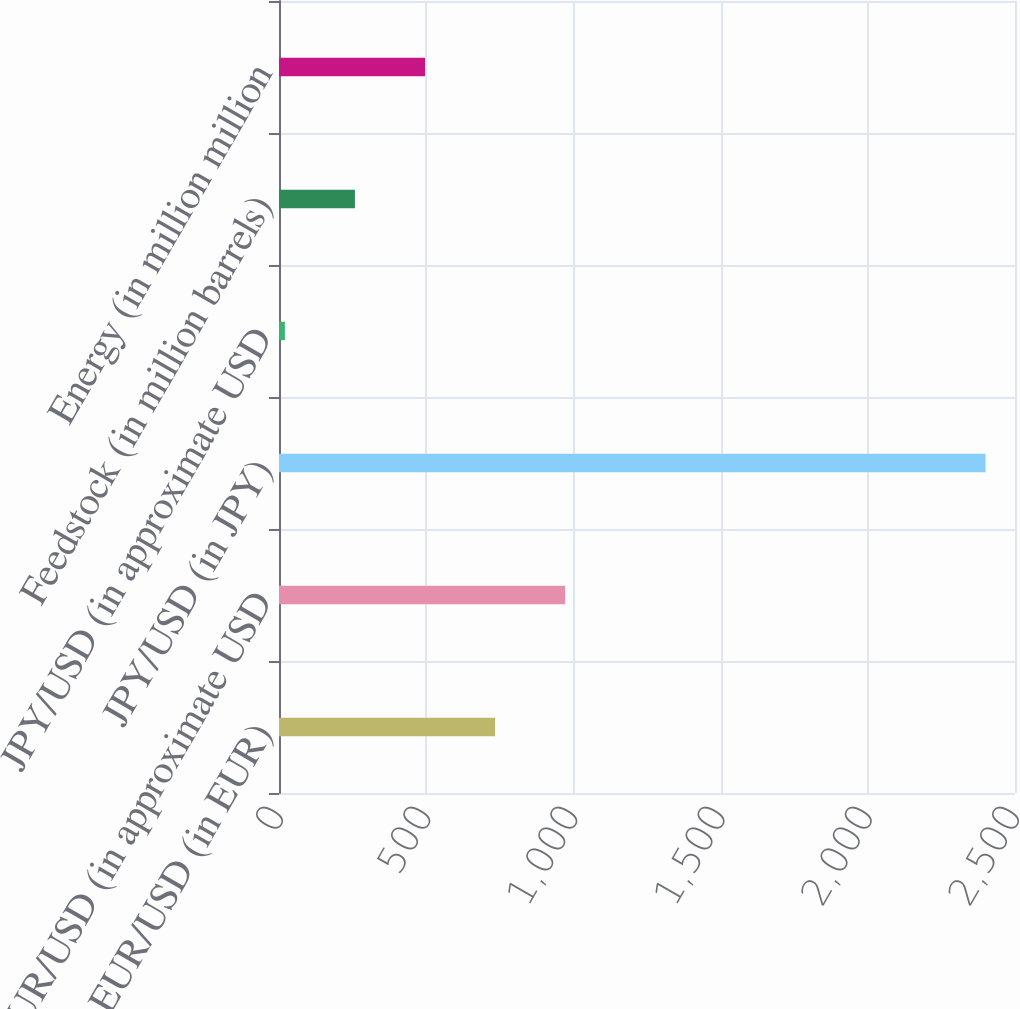Convert chart to OTSL. <chart><loc_0><loc_0><loc_500><loc_500><bar_chart><fcel>EUR/USD (in EUR)<fcel>EUR/USD (in approximate USD<fcel>JPY/USD (in JPY)<fcel>JPY/USD (in approximate USD<fcel>Feedstock (in million barrels)<fcel>Energy (in million million<nl><fcel>734<fcel>972<fcel>2400<fcel>20<fcel>258<fcel>496<nl></chart> 